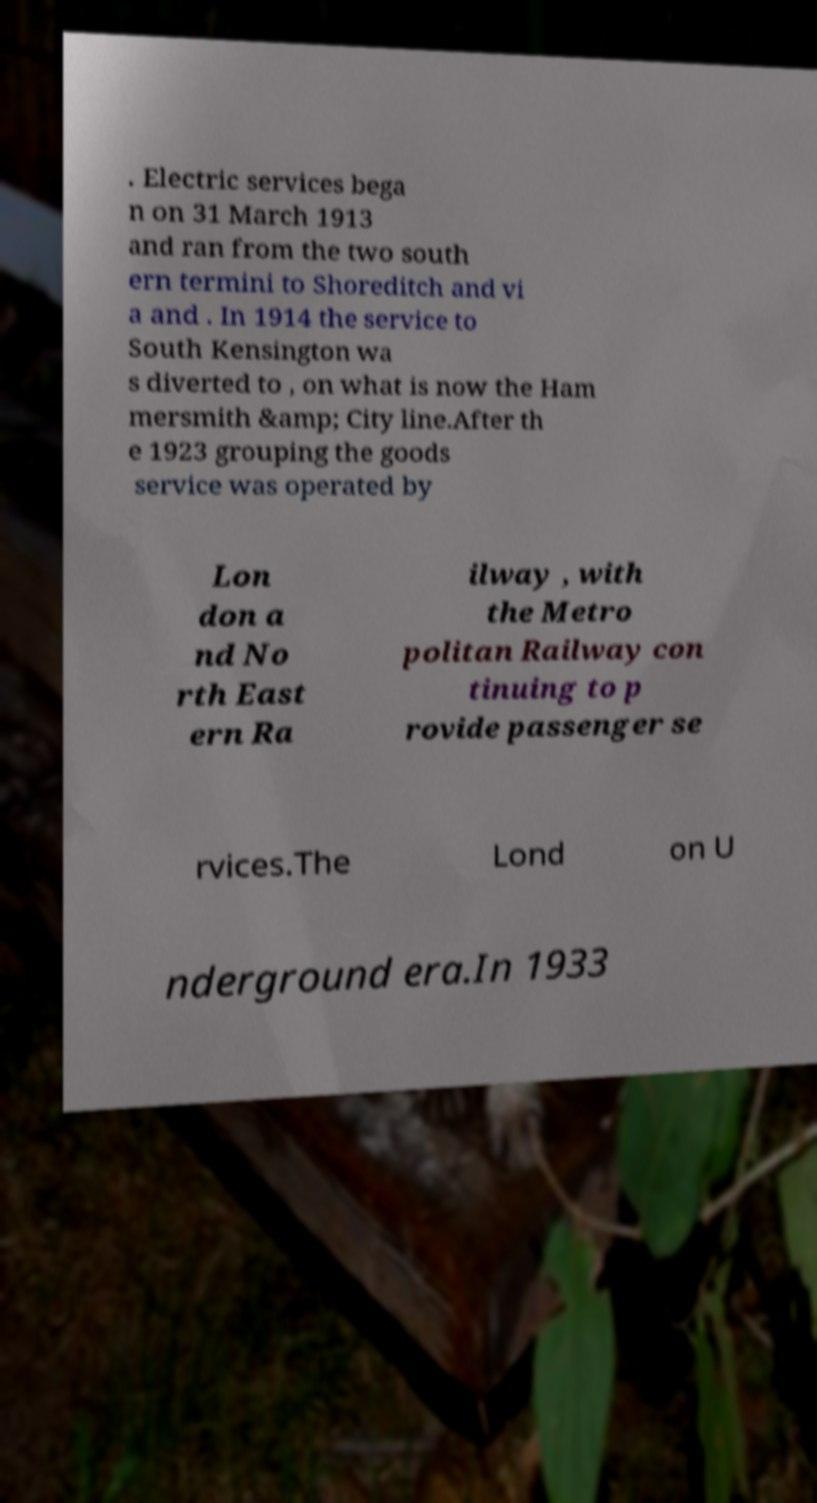Could you assist in decoding the text presented in this image and type it out clearly? . Electric services bega n on 31 March 1913 and ran from the two south ern termini to Shoreditch and vi a and . In 1914 the service to South Kensington wa s diverted to , on what is now the Ham mersmith &amp; City line.After th e 1923 grouping the goods service was operated by Lon don a nd No rth East ern Ra ilway , with the Metro politan Railway con tinuing to p rovide passenger se rvices.The Lond on U nderground era.In 1933 